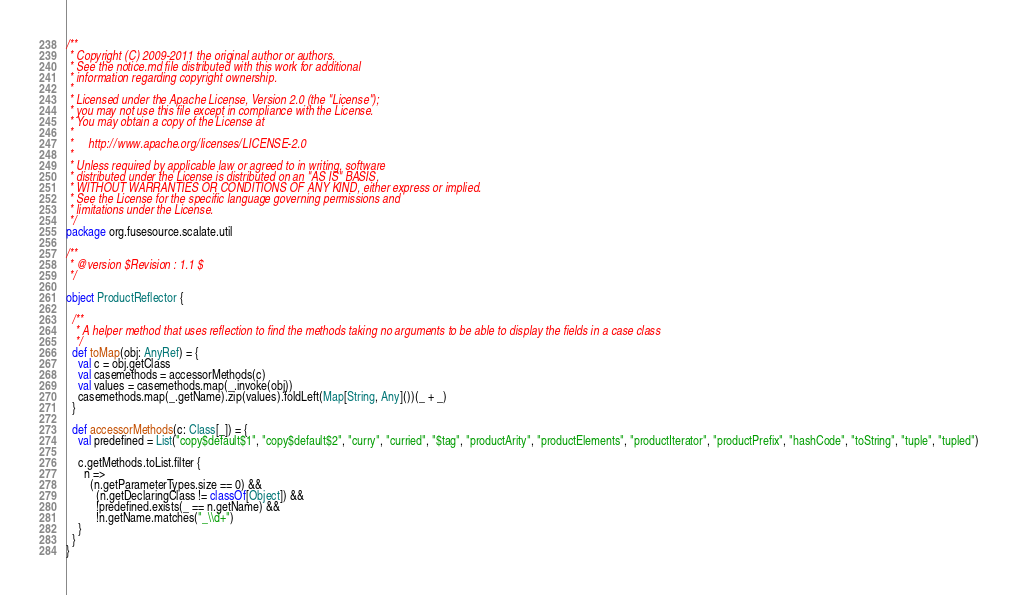<code> <loc_0><loc_0><loc_500><loc_500><_Scala_>/**
 * Copyright (C) 2009-2011 the original author or authors.
 * See the notice.md file distributed with this work for additional
 * information regarding copyright ownership.
 *
 * Licensed under the Apache License, Version 2.0 (the "License");
 * you may not use this file except in compliance with the License.
 * You may obtain a copy of the License at
 *
 *     http://www.apache.org/licenses/LICENSE-2.0
 *
 * Unless required by applicable law or agreed to in writing, software
 * distributed under the License is distributed on an "AS IS" BASIS,
 * WITHOUT WARRANTIES OR CONDITIONS OF ANY KIND, either express or implied.
 * See the License for the specific language governing permissions and
 * limitations under the License.
 */
package org.fusesource.scalate.util

/**
 * @version $Revision : 1.1 $
 */

object ProductReflector {

  /**
   * A helper method that uses reflection to find the methods taking no arguments to be able to display the fields in a case class
   */
  def toMap(obj: AnyRef) = {
    val c = obj.getClass
    val casemethods = accessorMethods(c)
    val values = casemethods.map(_.invoke(obj))
    casemethods.map(_.getName).zip(values).foldLeft(Map[String, Any]())(_ + _)
  }

  def accessorMethods(c: Class[_]) = {
    val predefined = List("copy$default$1", "copy$default$2", "curry", "curried", "$tag", "productArity", "productElements", "productIterator", "productPrefix", "hashCode", "toString", "tuple", "tupled")

    c.getMethods.toList.filter {
      n =>
        (n.getParameterTypes.size == 0) &&
          (n.getDeclaringClass != classOf[Object]) &&
          !predefined.exists(_ == n.getName) &&
          !n.getName.matches("_\\d+")
    }
  }
}
</code> 